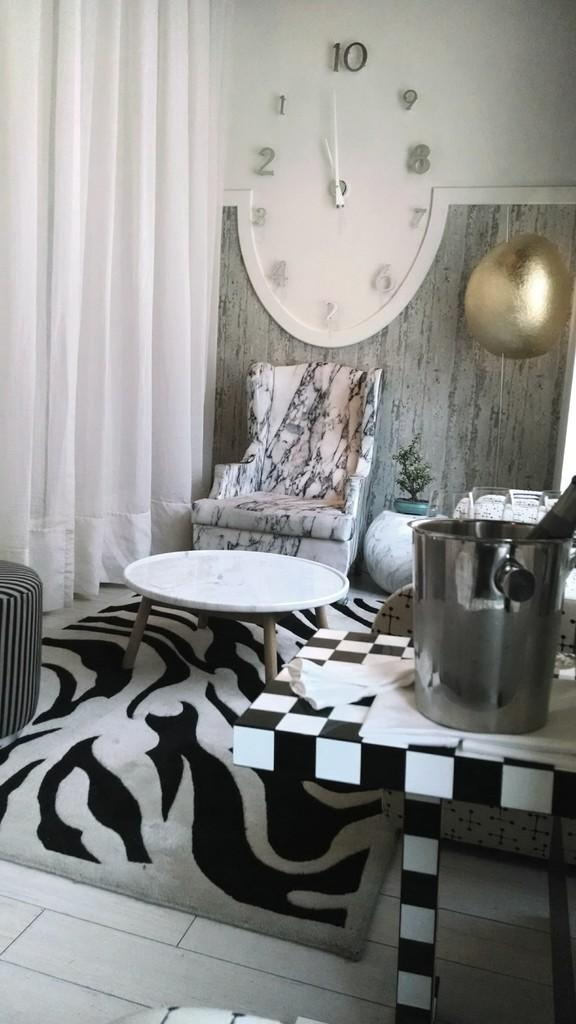Provide a one-sentence caption for the provided image. A huge oval clock points to the number 10. 